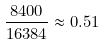Convert formula to latex. <formula><loc_0><loc_0><loc_500><loc_500>\frac { 8 4 0 0 } { 1 6 3 8 4 } \approx 0 . 5 1</formula> 